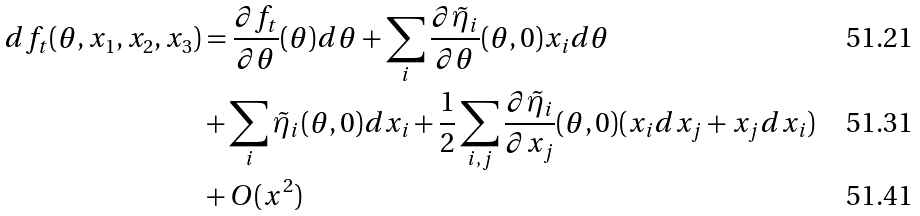Convert formula to latex. <formula><loc_0><loc_0><loc_500><loc_500>d f _ { t } ( \theta , x _ { 1 } , x _ { 2 } , x _ { 3 } ) & = \frac { \partial f _ { t } } { \partial \theta } ( \theta ) d \theta + \sum _ { i } \frac { \partial \tilde { \eta } _ { i } } { \partial \theta } ( \theta , 0 ) x _ { i } d \theta \\ & + \sum _ { i } \tilde { \eta } _ { i } ( \theta , 0 ) d x _ { i } + \frac { 1 } { 2 } \sum _ { i , j } \frac { \partial \tilde { \eta } _ { i } } { \partial x _ { j } } ( \theta , 0 ) ( x _ { i } d x _ { j } + x _ { j } d x _ { i } ) \\ & + O ( x ^ { 2 } )</formula> 